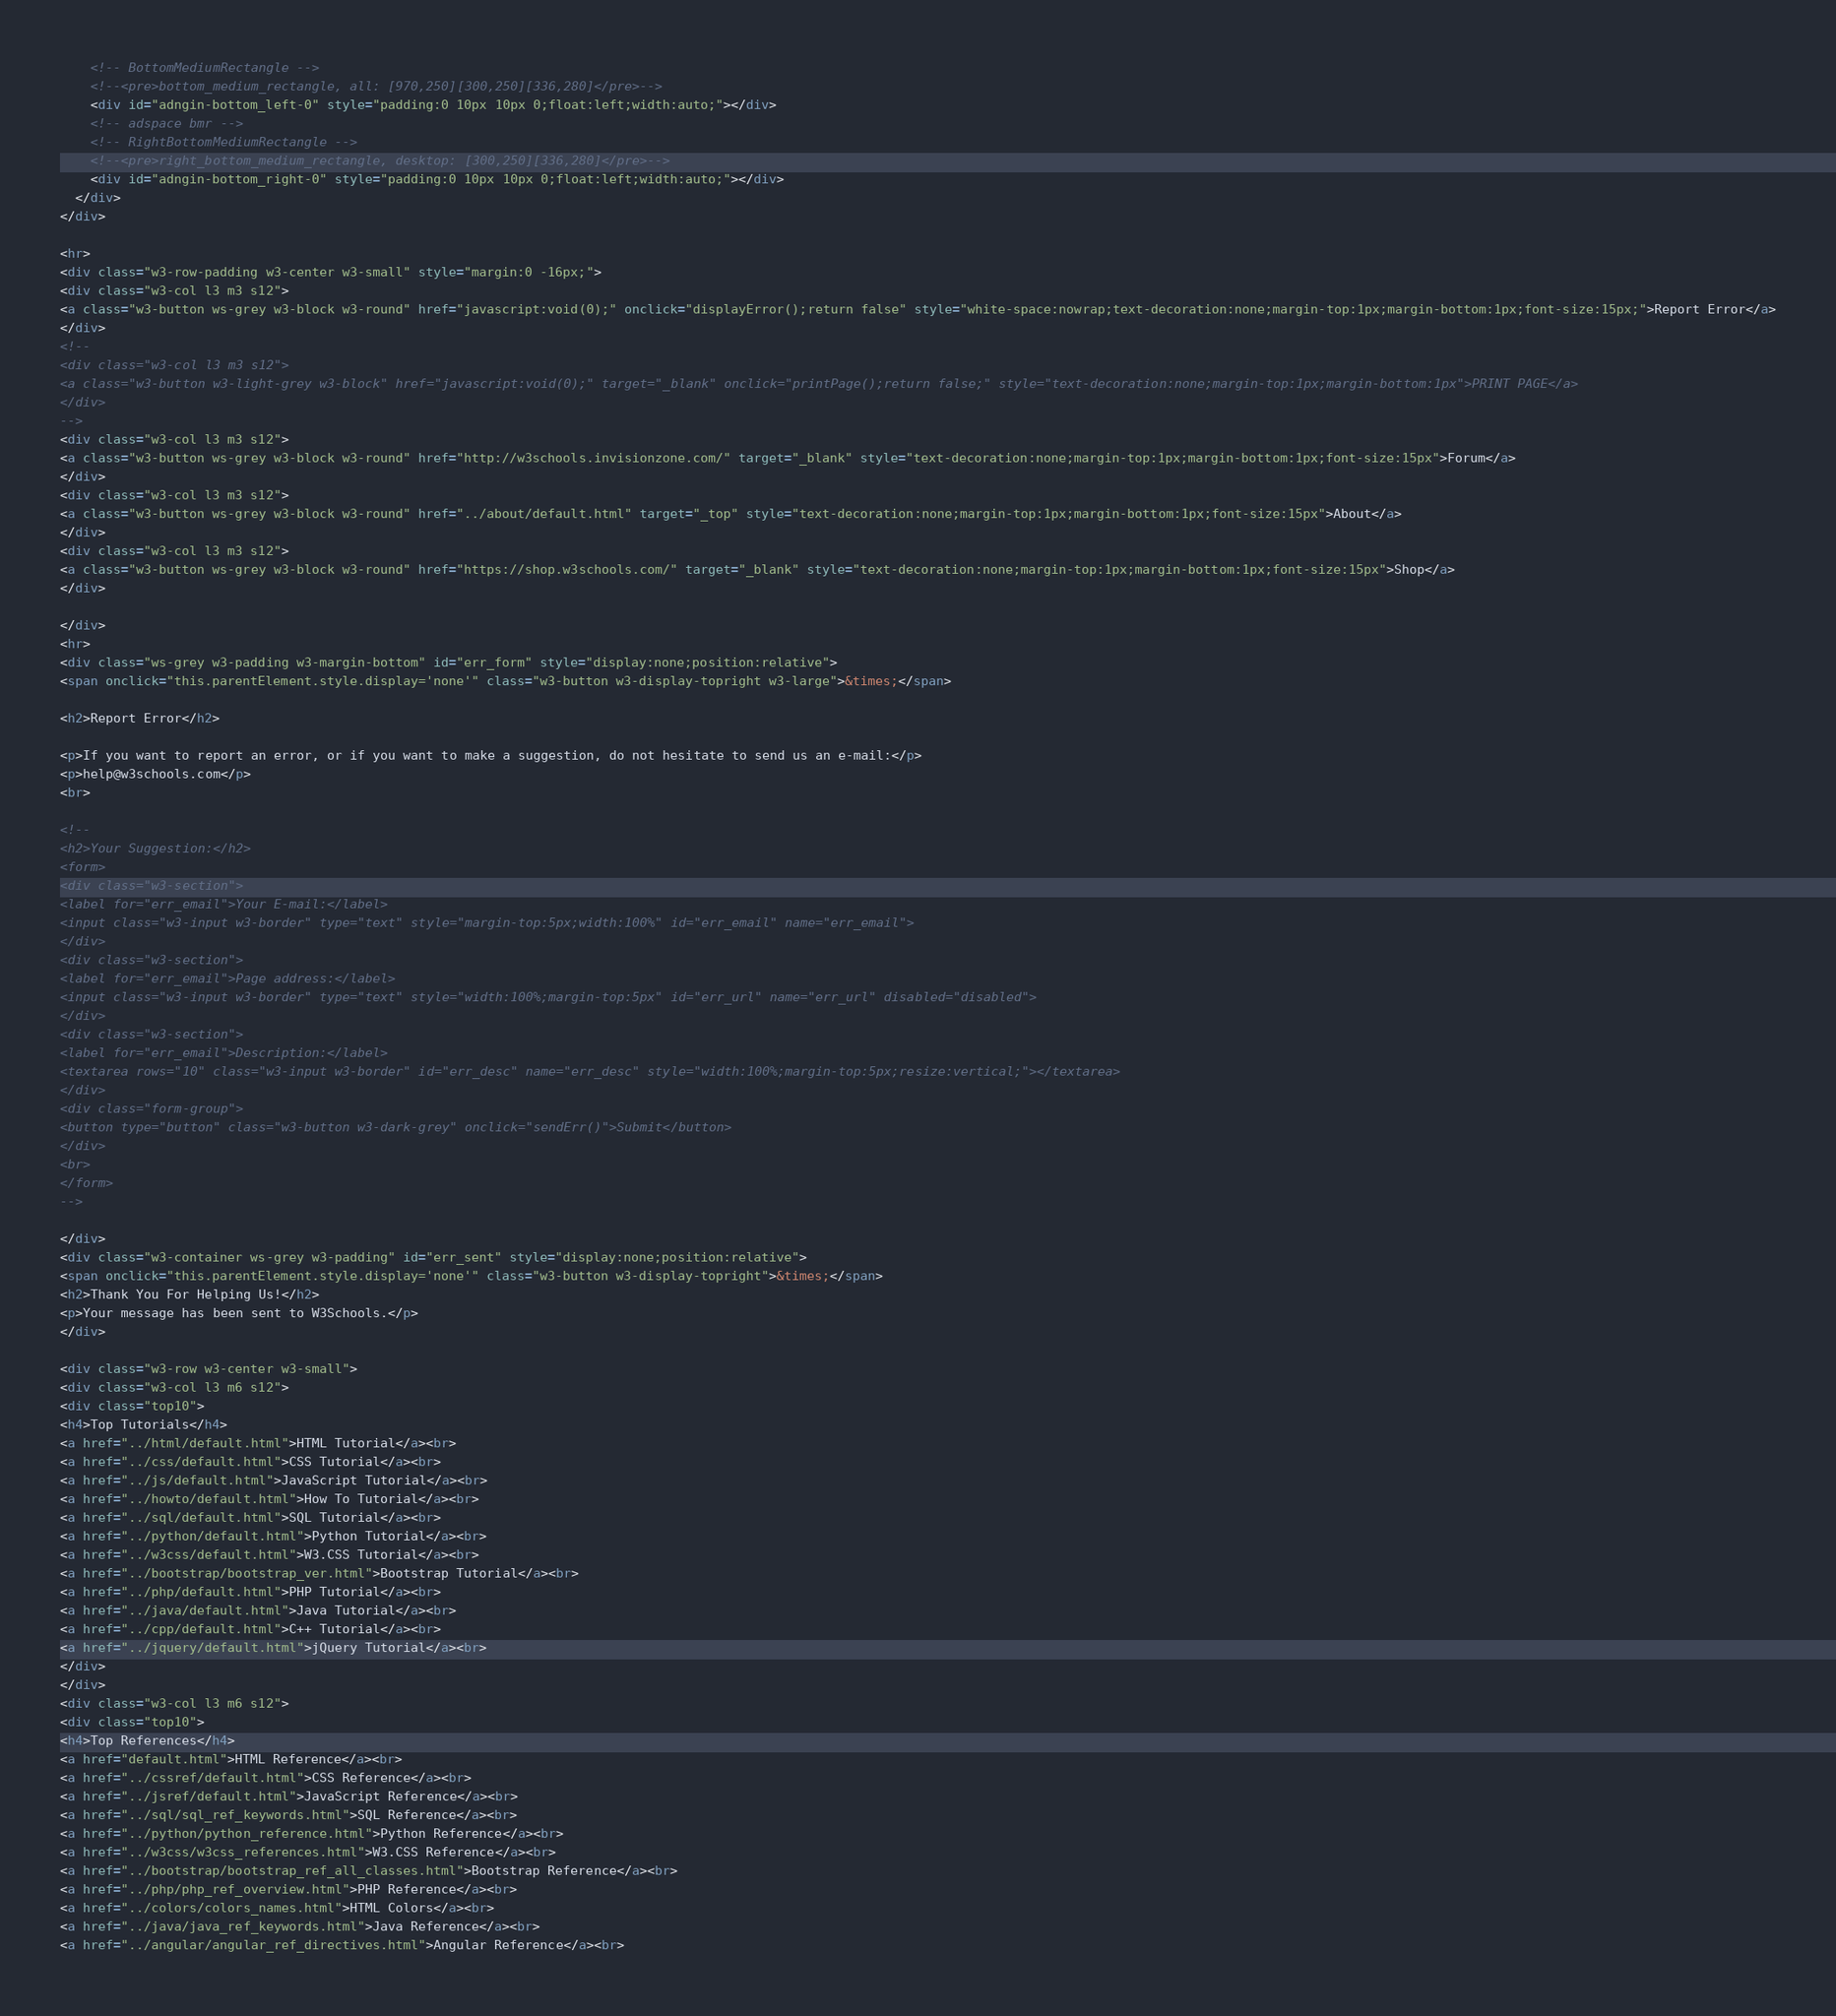Convert code to text. <code><loc_0><loc_0><loc_500><loc_500><_HTML_>    <!-- BottomMediumRectangle -->
    <!--<pre>bottom_medium_rectangle, all: [970,250][300,250][336,280]</pre>-->
    <div id="adngin-bottom_left-0" style="padding:0 10px 10px 0;float:left;width:auto;"></div>
    <!-- adspace bmr -->
    <!-- RightBottomMediumRectangle -->
    <!--<pre>right_bottom_medium_rectangle, desktop: [300,250][336,280]</pre>-->
    <div id="adngin-bottom_right-0" style="padding:0 10px 10px 0;float:left;width:auto;"></div>
  </div>
</div>

<hr>
<div class="w3-row-padding w3-center w3-small" style="margin:0 -16px;">
<div class="w3-col l3 m3 s12">
<a class="w3-button ws-grey w3-block w3-round" href="javascript:void(0);" onclick="displayError();return false" style="white-space:nowrap;text-decoration:none;margin-top:1px;margin-bottom:1px;font-size:15px;">Report Error</a>
</div>
<!--
<div class="w3-col l3 m3 s12">
<a class="w3-button w3-light-grey w3-block" href="javascript:void(0);" target="_blank" onclick="printPage();return false;" style="text-decoration:none;margin-top:1px;margin-bottom:1px">PRINT PAGE</a>
</div>
-->
<div class="w3-col l3 m3 s12">
<a class="w3-button ws-grey w3-block w3-round" href="http://w3schools.invisionzone.com/" target="_blank" style="text-decoration:none;margin-top:1px;margin-bottom:1px;font-size:15px">Forum</a>
</div>
<div class="w3-col l3 m3 s12">
<a class="w3-button ws-grey w3-block w3-round" href="../about/default.html" target="_top" style="text-decoration:none;margin-top:1px;margin-bottom:1px;font-size:15px">About</a>
</div>
<div class="w3-col l3 m3 s12">
<a class="w3-button ws-grey w3-block w3-round" href="https://shop.w3schools.com/" target="_blank" style="text-decoration:none;margin-top:1px;margin-bottom:1px;font-size:15px">Shop</a>
</div>

</div>
<hr>
<div class="ws-grey w3-padding w3-margin-bottom" id="err_form" style="display:none;position:relative">
<span onclick="this.parentElement.style.display='none'" class="w3-button w3-display-topright w3-large">&times;</span>

<h2>Report Error</h2>

<p>If you want to report an error, or if you want to make a suggestion, do not hesitate to send us an e-mail:</p>
<p>help@w3schools.com</p>
<br>

<!--
<h2>Your Suggestion:</h2>
<form>
<div class="w3-section">      
<label for="err_email">Your E-mail:</label>
<input class="w3-input w3-border" type="text" style="margin-top:5px;width:100%" id="err_email" name="err_email">
</div>
<div class="w3-section">      
<label for="err_email">Page address:</label>
<input class="w3-input w3-border" type="text" style="width:100%;margin-top:5px" id="err_url" name="err_url" disabled="disabled">
</div>
<div class="w3-section">
<label for="err_email">Description:</label>
<textarea rows="10" class="w3-input w3-border" id="err_desc" name="err_desc" style="width:100%;margin-top:5px;resize:vertical;"></textarea>
</div>
<div class="form-group">        
<button type="button" class="w3-button w3-dark-grey" onclick="sendErr()">Submit</button>
</div>
<br>
</form>
-->

</div>
<div class="w3-container ws-grey w3-padding" id="err_sent" style="display:none;position:relative">
<span onclick="this.parentElement.style.display='none'" class="w3-button w3-display-topright">&times;</span>     
<h2>Thank You For Helping Us!</h2>
<p>Your message has been sent to W3Schools.</p>
</div>

<div class="w3-row w3-center w3-small">
<div class="w3-col l3 m6 s12">
<div class="top10">
<h4>Top Tutorials</h4>
<a href="../html/default.html">HTML Tutorial</a><br>
<a href="../css/default.html">CSS Tutorial</a><br>
<a href="../js/default.html">JavaScript Tutorial</a><br>
<a href="../howto/default.html">How To Tutorial</a><br>
<a href="../sql/default.html">SQL Tutorial</a><br>
<a href="../python/default.html">Python Tutorial</a><br>
<a href="../w3css/default.html">W3.CSS Tutorial</a><br>
<a href="../bootstrap/bootstrap_ver.html">Bootstrap Tutorial</a><br>
<a href="../php/default.html">PHP Tutorial</a><br>
<a href="../java/default.html">Java Tutorial</a><br>
<a href="../cpp/default.html">C++ Tutorial</a><br>
<a href="../jquery/default.html">jQuery Tutorial</a><br>
</div>
</div>
<div class="w3-col l3 m6 s12">
<div class="top10">
<h4>Top References</h4>
<a href="default.html">HTML Reference</a><br>
<a href="../cssref/default.html">CSS Reference</a><br>
<a href="../jsref/default.html">JavaScript Reference</a><br>
<a href="../sql/sql_ref_keywords.html">SQL Reference</a><br>
<a href="../python/python_reference.html">Python Reference</a><br>
<a href="../w3css/w3css_references.html">W3.CSS Reference</a><br>
<a href="../bootstrap/bootstrap_ref_all_classes.html">Bootstrap Reference</a><br>
<a href="../php/php_ref_overview.html">PHP Reference</a><br>
<a href="../colors/colors_names.html">HTML Colors</a><br>
<a href="../java/java_ref_keywords.html">Java Reference</a><br>
<a href="../angular/angular_ref_directives.html">Angular Reference</a><br></code> 